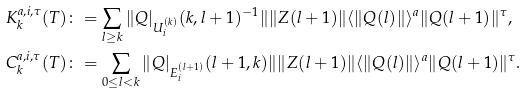<formula> <loc_0><loc_0><loc_500><loc_500>& K ^ { a , i , \tau } _ { k } ( T ) \colon = \sum _ { l \geq k } \| Q | _ { U ^ { ( k ) } _ { i } } ( k , l + 1 ) ^ { - 1 } \| \| Z ( l + 1 ) \| \langle \| Q ( l ) \| \rangle ^ { a } \| Q ( l + 1 ) \| ^ { \tau } , \\ & C ^ { a , i , \tau } _ { k } ( T ) \colon = \sum _ { 0 \leq l < k } \| Q | _ { E ^ { ( l + 1 ) } _ { i } } ( l + 1 , k ) \| \| Z ( l + 1 ) \| \langle \| Q ( l ) \| \rangle ^ { a } \| Q ( l + 1 ) \| ^ { \tau } .</formula> 